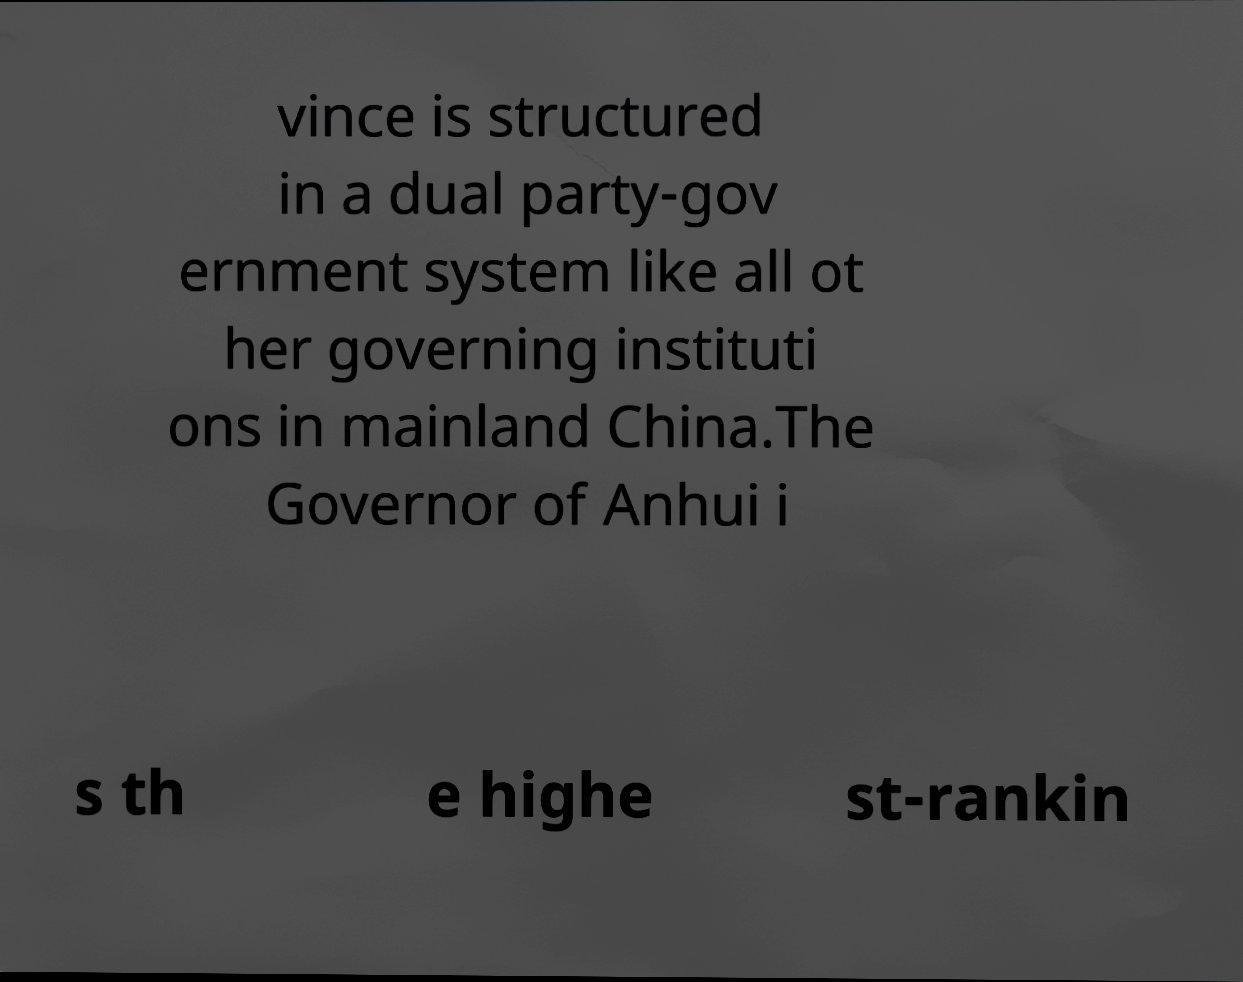There's text embedded in this image that I need extracted. Can you transcribe it verbatim? vince is structured in a dual party-gov ernment system like all ot her governing instituti ons in mainland China.The Governor of Anhui i s th e highe st-rankin 